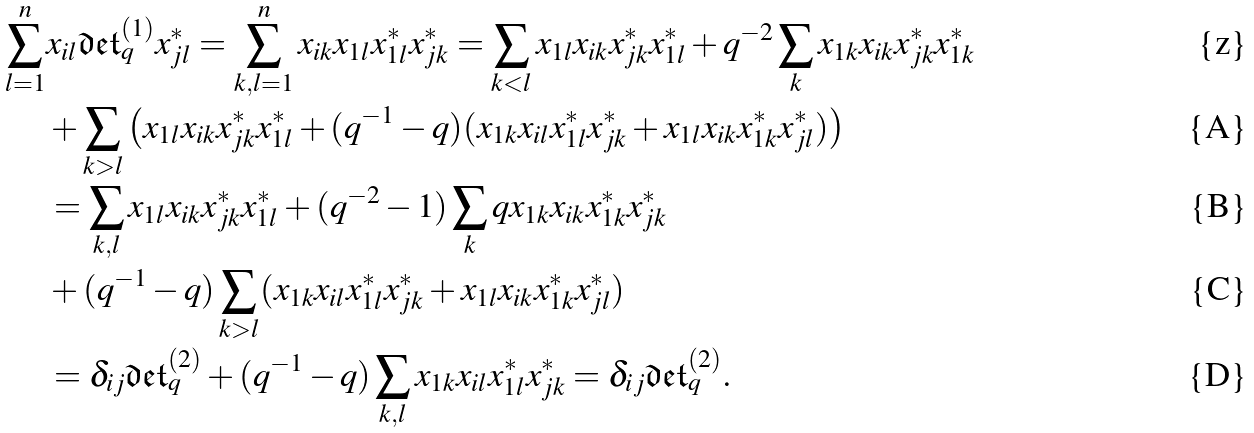Convert formula to latex. <formula><loc_0><loc_0><loc_500><loc_500>\sum _ { l = 1 } ^ { n } & x _ { i l } \mathfrak { d e t } _ { q } ^ { ( 1 ) } x _ { j l } ^ { * } = \sum _ { k , l = 1 } ^ { n } x _ { i k } x _ { 1 l } x _ { 1 l } ^ { * } x _ { j k } ^ { * } = \sum _ { k < l } x _ { 1 l } x _ { i k } x _ { j k } ^ { * } x _ { 1 l } ^ { * } + q ^ { - 2 } \sum _ { k } x _ { 1 k } x _ { i k } x _ { j k } ^ { * } x _ { 1 k } ^ { * } \\ & + \sum _ { k > l } \left ( x _ { 1 l } x _ { i k } x _ { j k } ^ { * } x _ { 1 l } ^ { * } + ( q ^ { - 1 } - q ) ( x _ { 1 k } x _ { i l } x _ { 1 l } ^ { * } x _ { j k } ^ { * } + x _ { 1 l } x _ { i k } x _ { 1 k } ^ { * } x _ { j l } ^ { * } ) \right ) \\ & = \sum _ { k , l } x _ { 1 l } x _ { i k } x _ { j k } ^ { * } x _ { 1 l } ^ { * } + ( q ^ { - 2 } - 1 ) \sum _ { k } q x _ { 1 k } x _ { i k } x _ { 1 k } ^ { * } x _ { j k } ^ { * } \\ & + ( q ^ { - 1 } - q ) \sum _ { k > l } ( x _ { 1 k } x _ { i l } x _ { 1 l } ^ { * } x _ { j k } ^ { * } + x _ { 1 l } x _ { i k } x _ { 1 k } ^ { * } x _ { j l } ^ { * } ) \\ & = \delta _ { i j } \mathfrak { d e t } _ { q } ^ { ( 2 ) } + ( q ^ { - 1 } - q ) \sum _ { k , l } x _ { 1 k } x _ { i l } x _ { 1 l } ^ { * } x _ { j k } ^ { * } = \delta _ { i j } \mathfrak { d e t } _ { q } ^ { ( 2 ) } .</formula> 